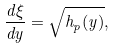<formula> <loc_0><loc_0><loc_500><loc_500>\frac { d \xi } { d y } = \sqrt { h _ { p } ( y ) } ,</formula> 